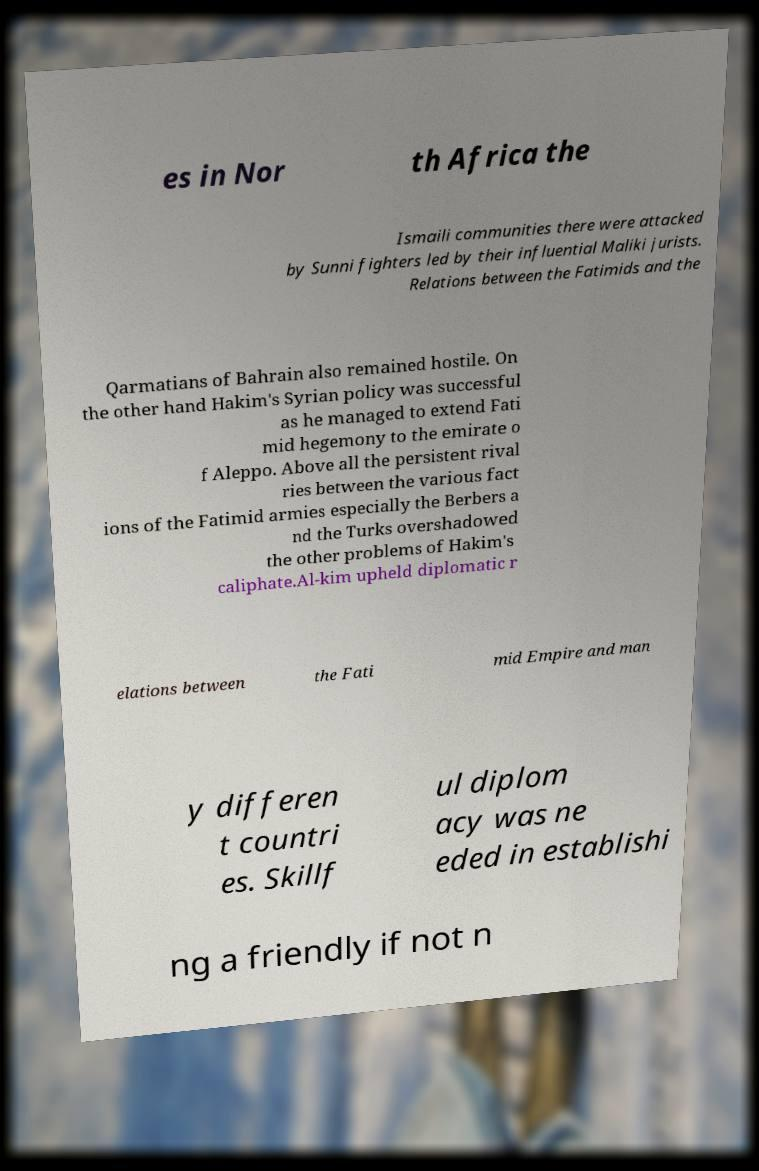What messages or text are displayed in this image? I need them in a readable, typed format. es in Nor th Africa the Ismaili communities there were attacked by Sunni fighters led by their influential Maliki jurists. Relations between the Fatimids and the Qarmatians of Bahrain also remained hostile. On the other hand Hakim's Syrian policy was successful as he managed to extend Fati mid hegemony to the emirate o f Aleppo. Above all the persistent rival ries between the various fact ions of the Fatimid armies especially the Berbers a nd the Turks overshadowed the other problems of Hakim's caliphate.Al-kim upheld diplomatic r elations between the Fati mid Empire and man y differen t countri es. Skillf ul diplom acy was ne eded in establishi ng a friendly if not n 